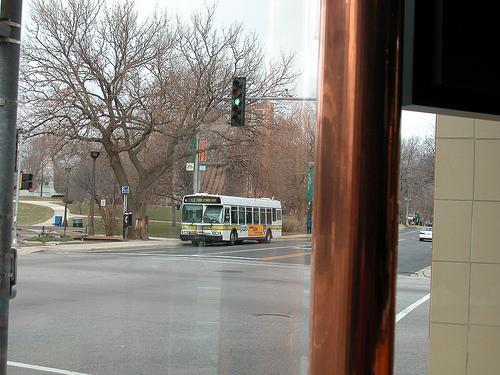How many people are in the photo?
Give a very brief answer. 0. 